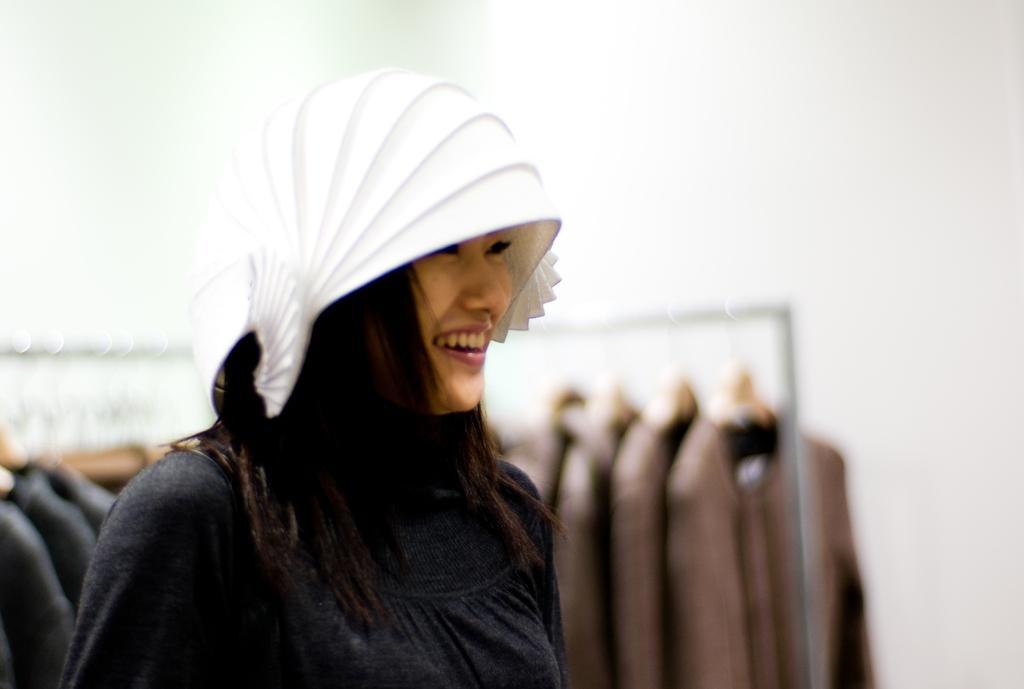Could you give a brief overview of what you see in this image? There is one woman standing and wearing a black color cap at the bottom of this image. We can see clothes are hanging from the hangers. There is a wall in the background. 